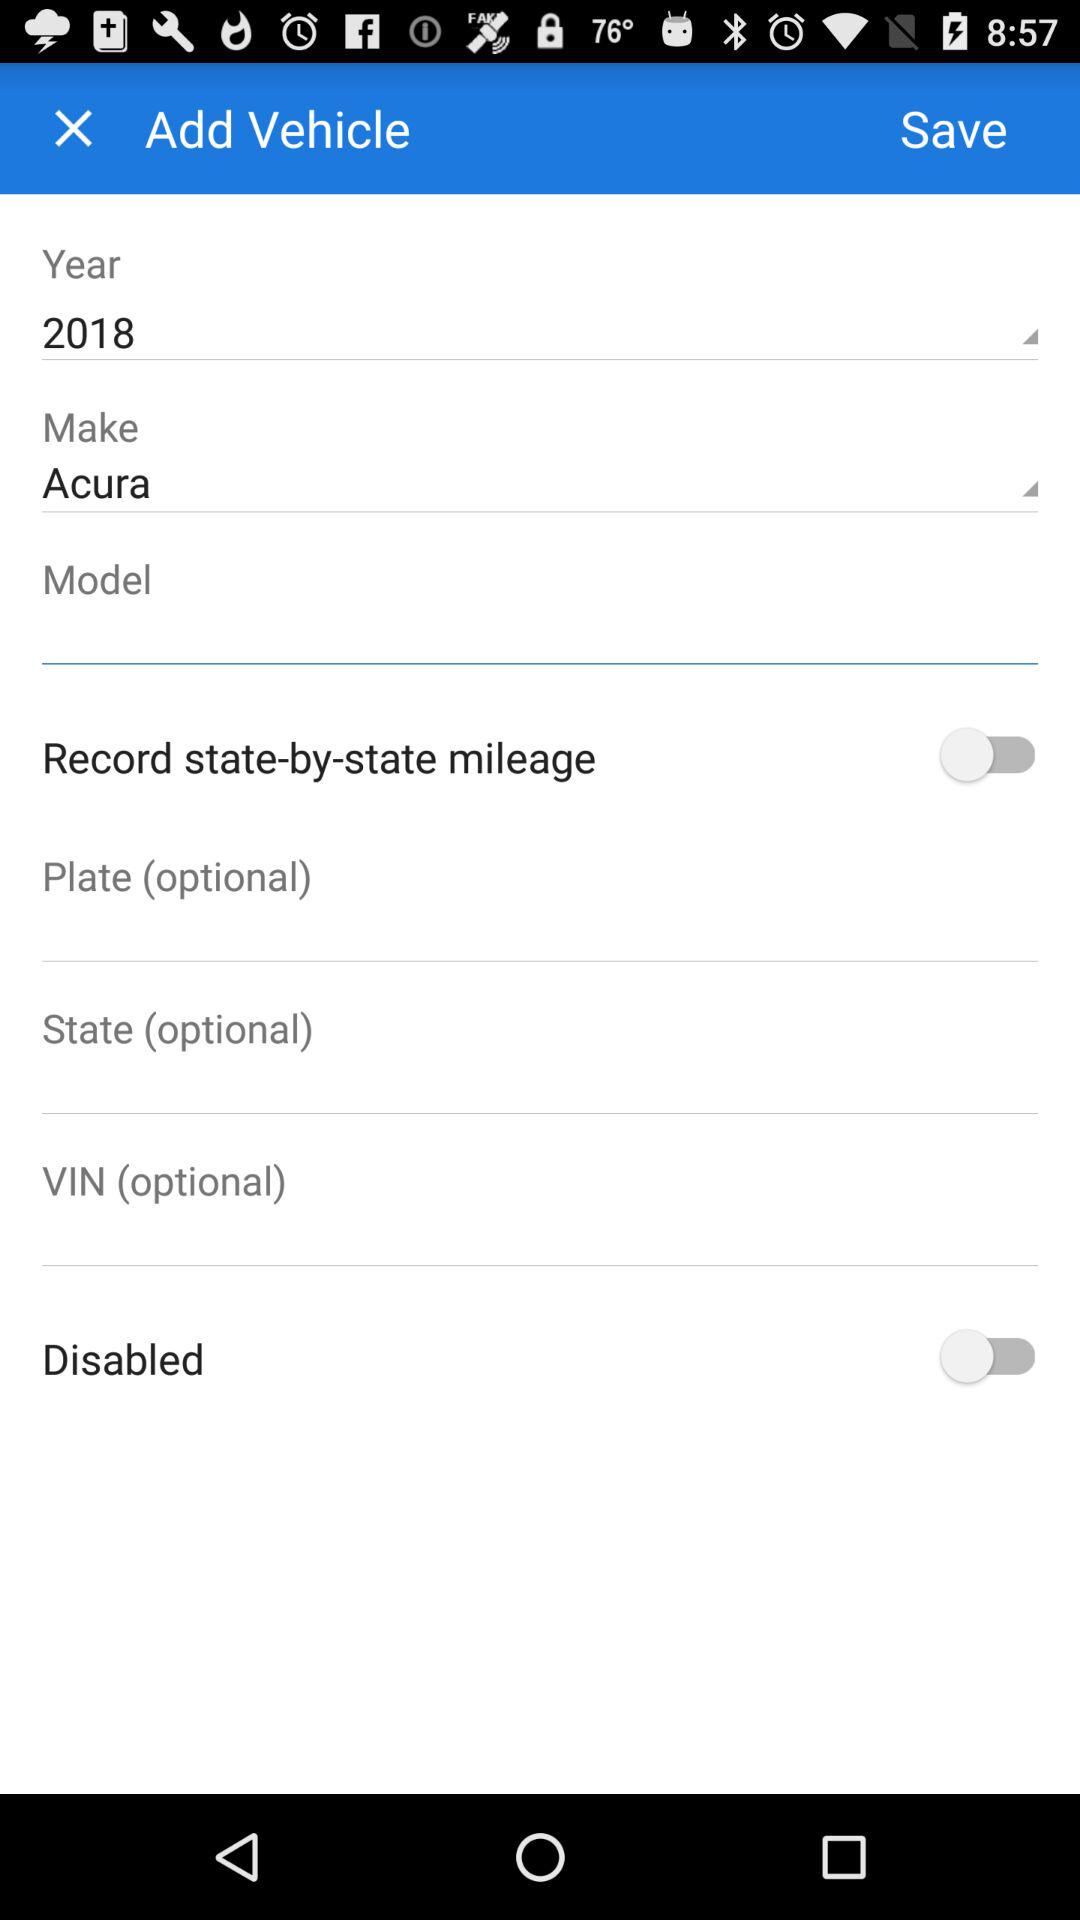What is the status of the "Record state by state mileage"? The status is "off". 